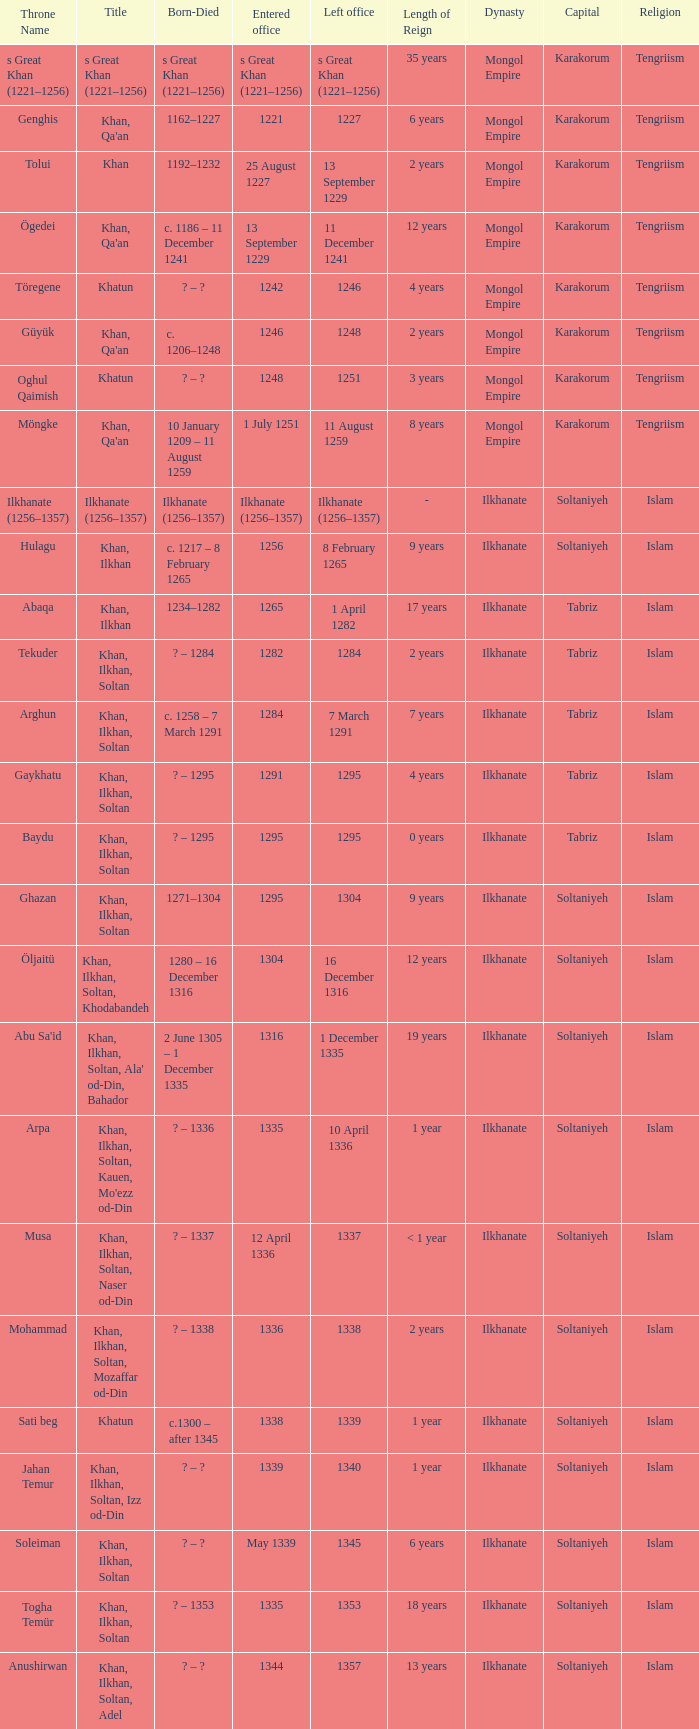What is the born-died that has office of 13 September 1229 as the entered? C. 1186 – 11 december 1241. 